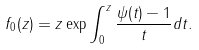<formula> <loc_0><loc_0><loc_500><loc_500>f _ { 0 } ( z ) = z \exp { \int _ { 0 } ^ { z } \frac { \psi ( t ) - 1 } { t } d t } .</formula> 